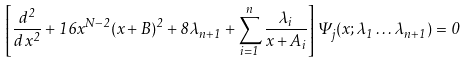<formula> <loc_0><loc_0><loc_500><loc_500>\left [ { \frac { d ^ { 2 } } { d \, x ^ { 2 } } } + 1 6 x ^ { N - 2 } ( x + B ) ^ { 2 } + 8 \lambda _ { n + 1 } + \sum _ { i = 1 } ^ { n } { \frac { \lambda _ { i } } { x + A _ { i } } } \right ] \Psi _ { j } ( x ; \lambda _ { 1 } \dots \lambda _ { n + 1 } ) = 0</formula> 